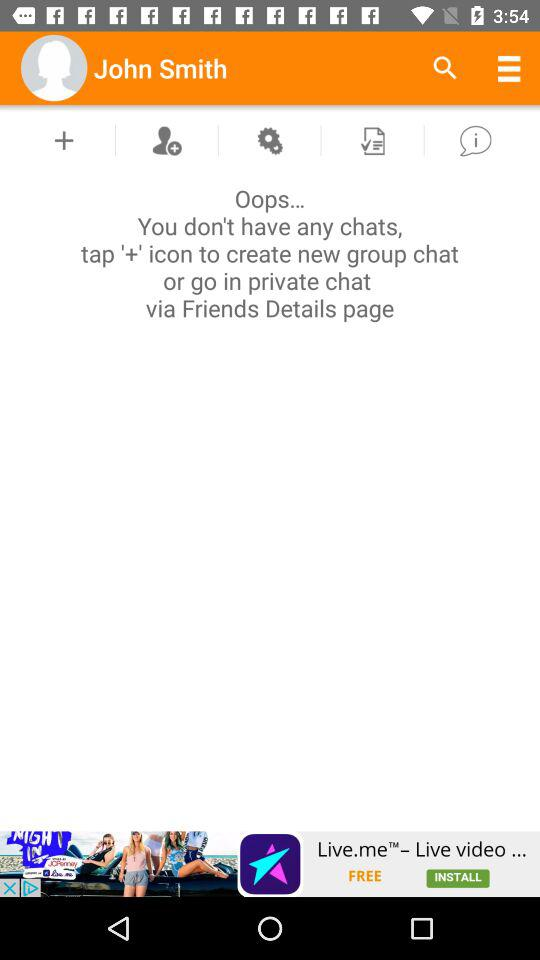Are there any available chats? There are no available chats. 